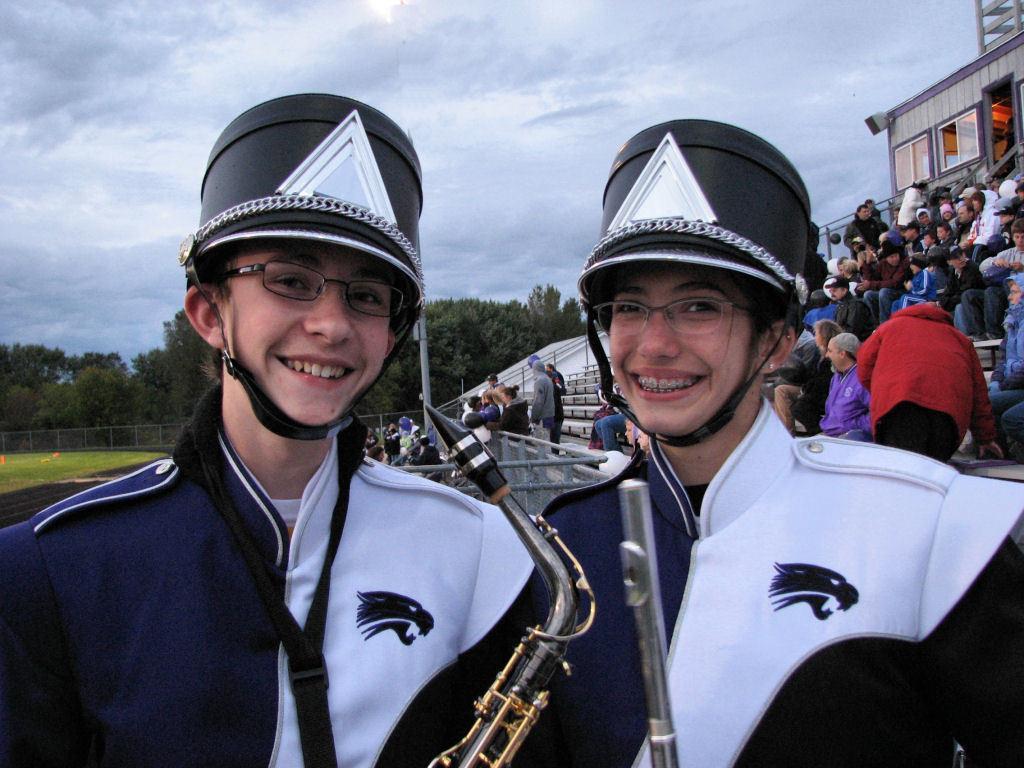How would you summarize this image in a sentence or two? In the foreground of the image we can see two persons wearing dress, spectacles and hats are holding a musical instrument in their hands. In the background, we can see a staircase, metal fence, group of audience, a group of trees and the cloudy sky. 